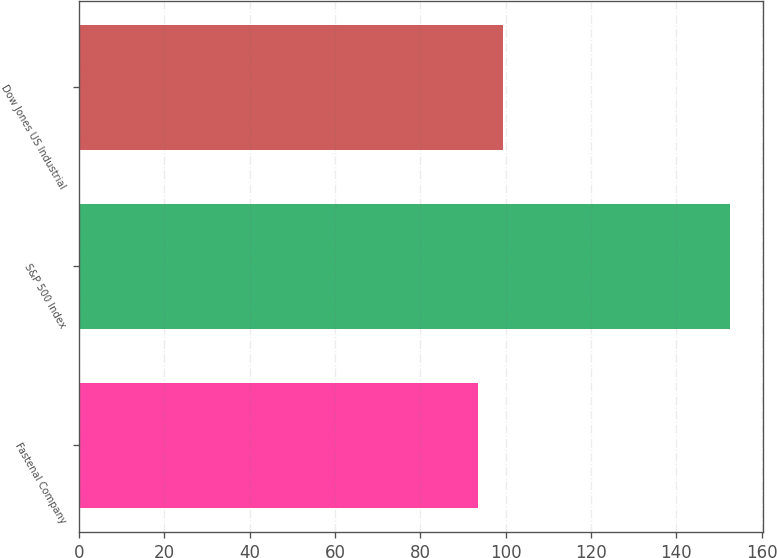Convert chart to OTSL. <chart><loc_0><loc_0><loc_500><loc_500><bar_chart><fcel>Fastenal Company<fcel>S&P 500 Index<fcel>Dow Jones US Industrial<nl><fcel>93.47<fcel>152.59<fcel>99.38<nl></chart> 